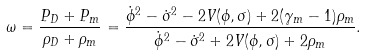Convert formula to latex. <formula><loc_0><loc_0><loc_500><loc_500>\omega = \frac { P _ { D } + P _ { m } } { \rho _ { D } + \rho _ { m } } = \frac { \dot { \phi } ^ { 2 } - \dot { \sigma } ^ { 2 } - 2 V ( \phi , \sigma ) + 2 ( \gamma _ { m } - 1 ) \rho _ { m } } { \dot { \phi } ^ { 2 } - \dot { \sigma } ^ { 2 } + 2 V ( \phi , \sigma ) + 2 \rho _ { m } } .</formula> 